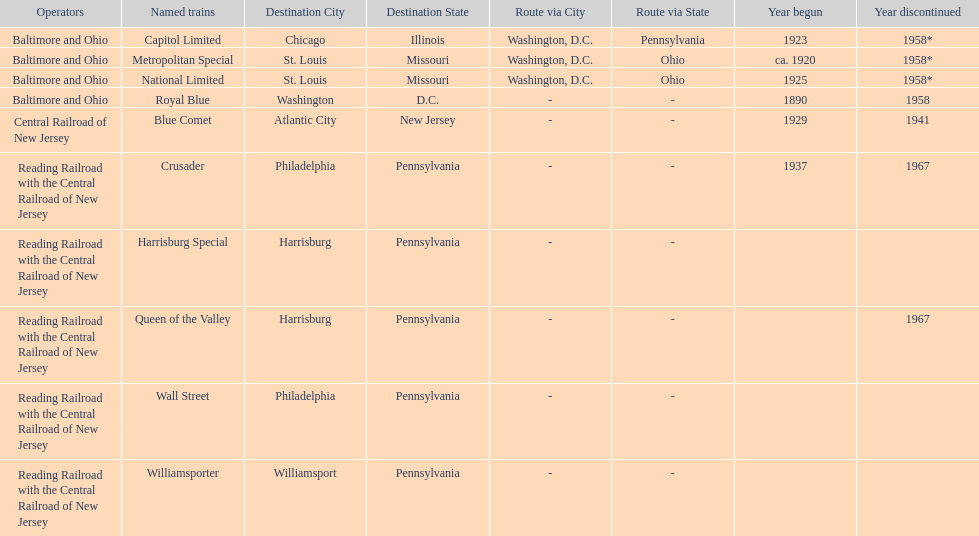Which train ran for the longest time? Royal Blue. 